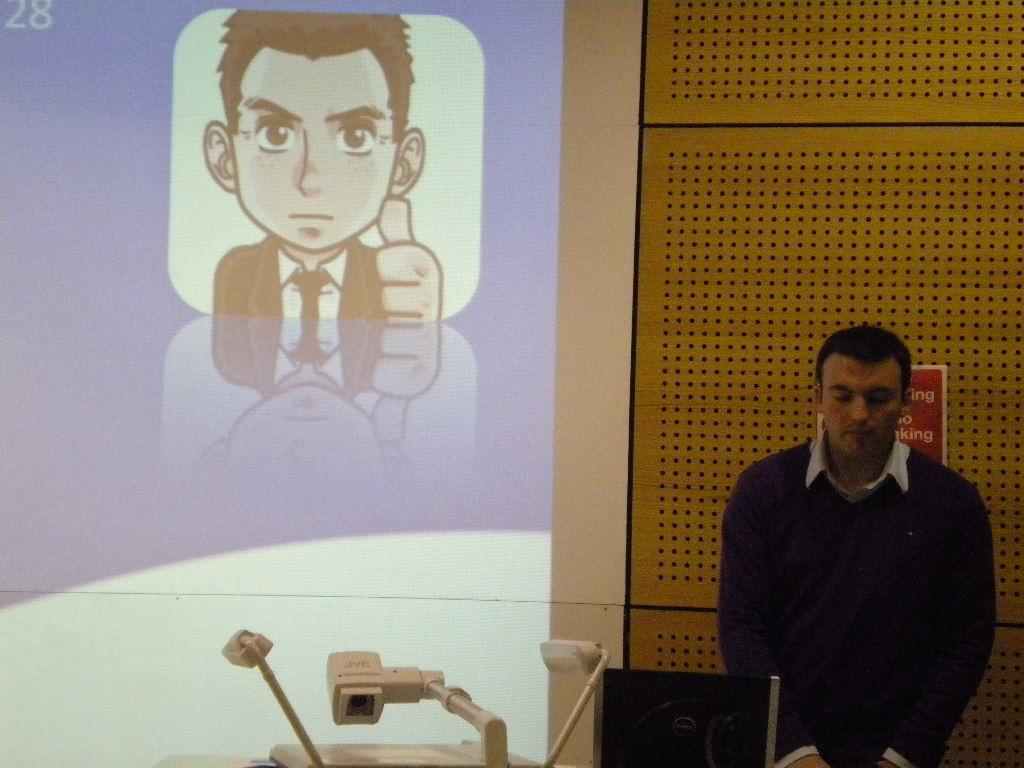What is the main subject in the image? There is a man standing in the image. What is the man standing in front of? There is a projector screen in the image. What is displayed on the projector screen? A cartoon image of a man is displayed on the screen. What color are the objects in the image? There are white color objects in the image. What type of offer is the man making to the audience in the image? There is no indication in the image that the man is making any offer to an audience. 